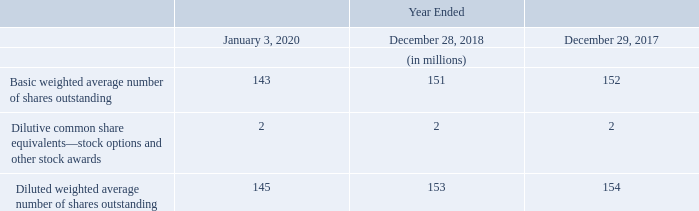Note 19—Earnings Per Share ("EPS")
Basic EPS is computed by dividing net income attributable to Leidos common stockholders by the basic weighted average number of shares outstanding. Diluted EPS is calculated to give effect to all potentially dilutive common shares that were outstanding during the reporting period. The dilutive effect of outstanding equity-based compensation awards is reflected in diluted EPS by application of the treasury stock method, only in periods in which such effect would have been dilutive for the period.
The Company issues unvested stock awards that have forfeitable rights to dividends or dividend equivalents. These stock awards are dilutive common share equivalents subject to the treasury stock method.
The weighted average number of shares used to compute basic and diluted EPS attributable to Leidos stockholders were:
Anti-dilutive stock-based awards are excluded from the weighted average number of shares outstanding used to compute diluted EPS. For fiscal 2019 and 2017, there were no significant anti-diluted equity awards. For fiscal 2018, there was 1 million of outstanding stock options and vesting stock awards that were anti-dilutive.
How is the Basic EPS calculated? By dividing net income attributable to leidos common stockholders by the basic weighted average number of shares outstanding. What was the outstanding stock options and vested stock awards in 2018? 1 million. What was the Basic weighted average number of shares outstanding in 2020, 2018 and 2017 respectively?
Answer scale should be: million. 143, 151, 152. In which year was Diluted weighted average number of shares outstanding less than 150 million? Locate and analyze diluted weighted average number of shares outstanding in row 6
answer: 2020. What was the change in the Basic weighted average number of shares outstanding from 2017 to 2018?
Answer scale should be: million. 151 - 152
Answer: -1. What was the change in the Diluted weighted average number of shares outstanding from 2017 to 2018?
Answer scale should be: million. 153 - 154
Answer: -1. 